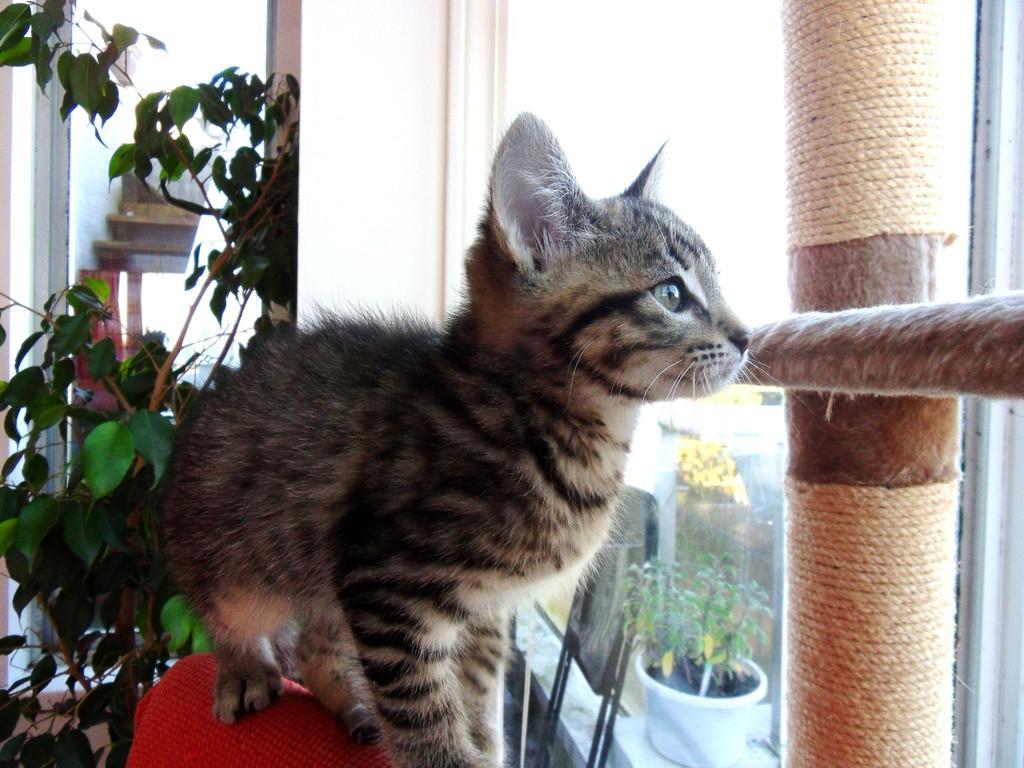Could you give a brief overview of what you see in this image? In front of the image there is a cat standing on the chair. Behind the cat there is a plant and a few other objects. In front of the cat there are wooden poles with rope. There is a glass window through which we can see a flower pot and a chair. 